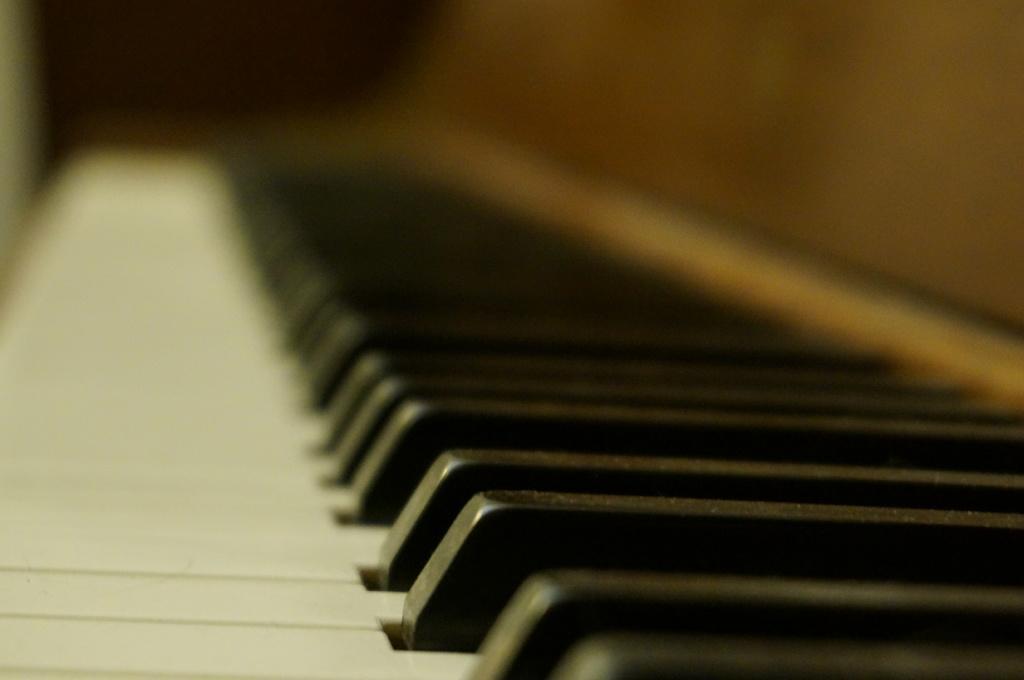How would you summarize this image in a sentence or two? In this image i can see a piano. 